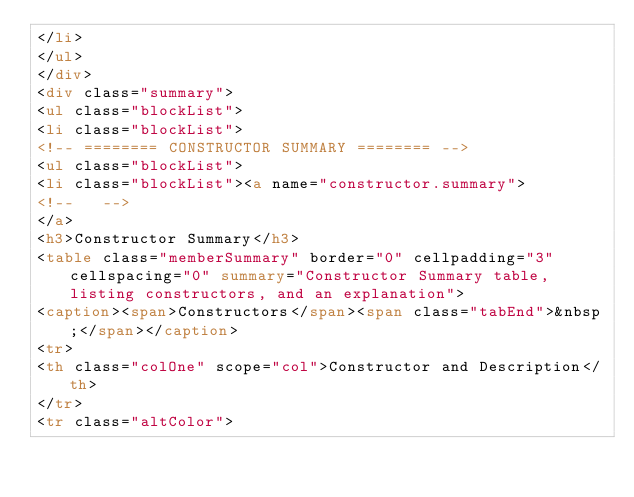Convert code to text. <code><loc_0><loc_0><loc_500><loc_500><_HTML_></li>
</ul>
</div>
<div class="summary">
<ul class="blockList">
<li class="blockList">
<!-- ======== CONSTRUCTOR SUMMARY ======== -->
<ul class="blockList">
<li class="blockList"><a name="constructor.summary">
<!--   -->
</a>
<h3>Constructor Summary</h3>
<table class="memberSummary" border="0" cellpadding="3" cellspacing="0" summary="Constructor Summary table, listing constructors, and an explanation">
<caption><span>Constructors</span><span class="tabEnd">&nbsp;</span></caption>
<tr>
<th class="colOne" scope="col">Constructor and Description</th>
</tr>
<tr class="altColor"></code> 